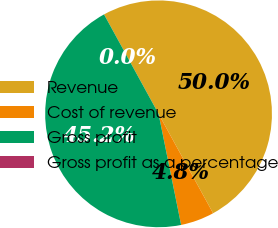Convert chart to OTSL. <chart><loc_0><loc_0><loc_500><loc_500><pie_chart><fcel>Revenue<fcel>Cost of revenue<fcel>Gross profit<fcel>Gross profit as a percentage<nl><fcel>50.0%<fcel>4.8%<fcel>45.2%<fcel>0.0%<nl></chart> 